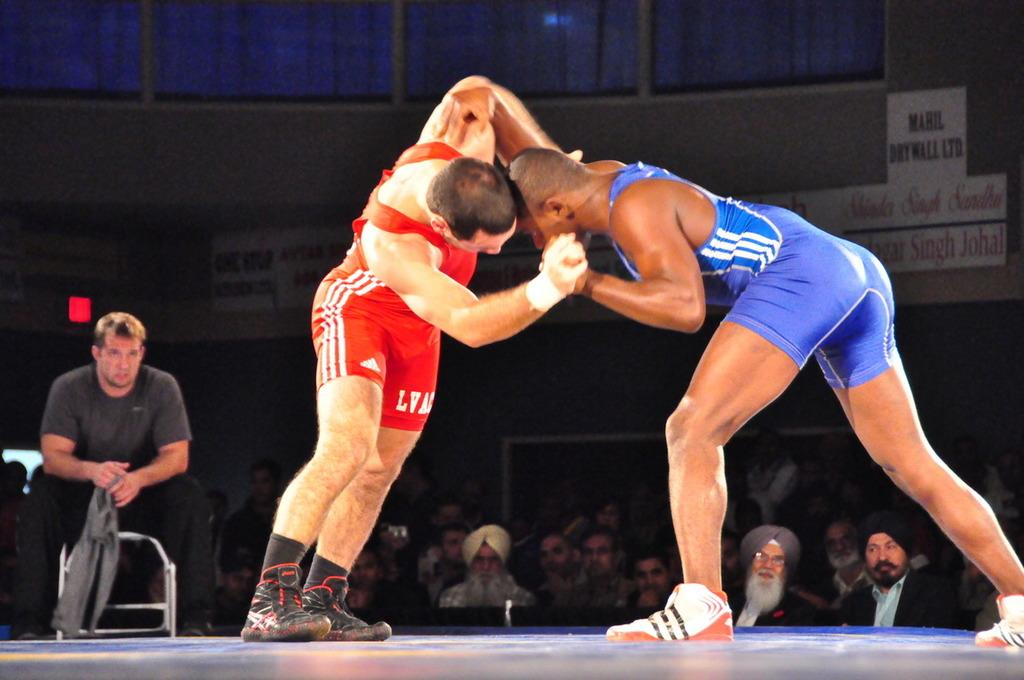<image>
Give a short and clear explanation of the subsequent image. The red wrestler wears an Adidas singlet while clinched with his opponent. 